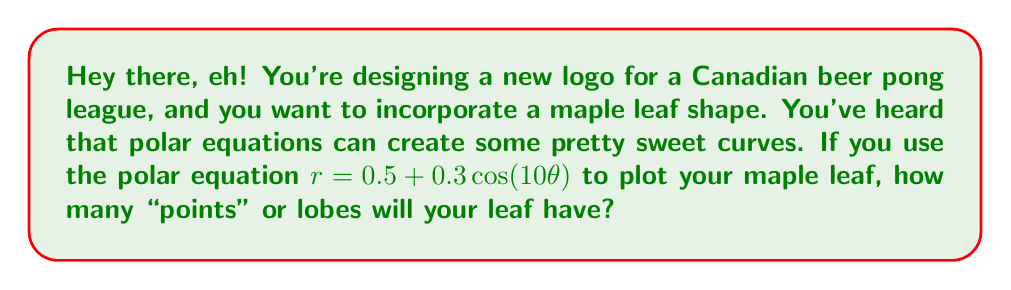Solve this math problem. Alright, let's break this down over a virtual round of beer pong:

1) In a polar equation of the form $r = a + b \cos(n\theta)$, the number $n$ determines how many lobes or "points" the shape will have.

2) In our equation $r = 0.5 + 0.3 \cos(10\theta)$, we can see that $n = 10$.

3) However, there's a catch! When $n$ is even, as it is in this case, the number of lobes is actually half of $n$.

4) This is because when $n$ is even, the shape completes a full rotation in $\pi$ radians instead of $2\pi$ radians.

5) So, to get the number of lobes, we divide $n$ by 2:

   Number of lobes = $\frac{n}{2} = \frac{10}{2} = 5$

Here's a quick visualization of what this would look like:

[asy]
import graph;
size(200);
real r(real theta) {return 0.5 + 0.3*cos(10*theta);}
path g=polargraph(r,0,2pi,300);
draw(g,red);
draw(Circle(0,0.5),dashed);
for(int i=0; i<5; ++i) {
  draw((0.8*cos(2pi*i/5),0.8*sin(2pi*i/5))--(0,0),blue);
}
[/asy]

The blue lines highlight the 5 main lobes of the maple leaf shape.
Answer: The maple leaf shape will have 5 lobes or points. 